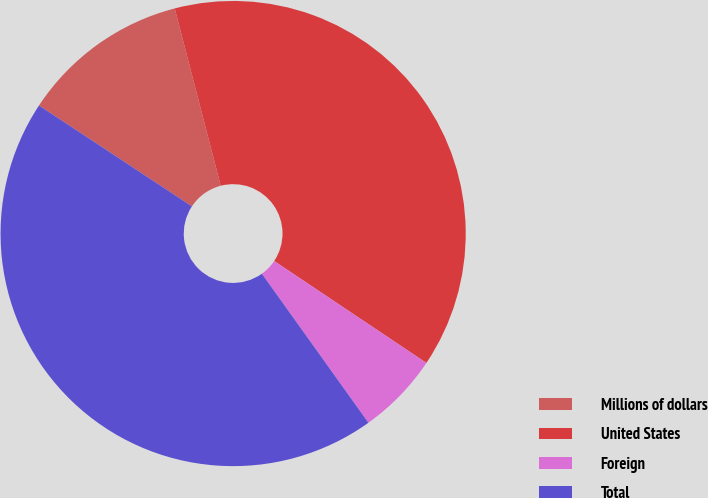<chart> <loc_0><loc_0><loc_500><loc_500><pie_chart><fcel>Millions of dollars<fcel>United States<fcel>Foreign<fcel>Total<nl><fcel>11.68%<fcel>38.43%<fcel>5.73%<fcel>44.16%<nl></chart> 